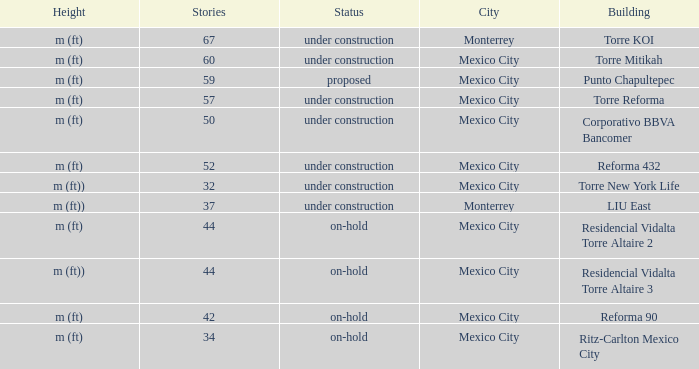How tall is the 52 story building? M (ft). 